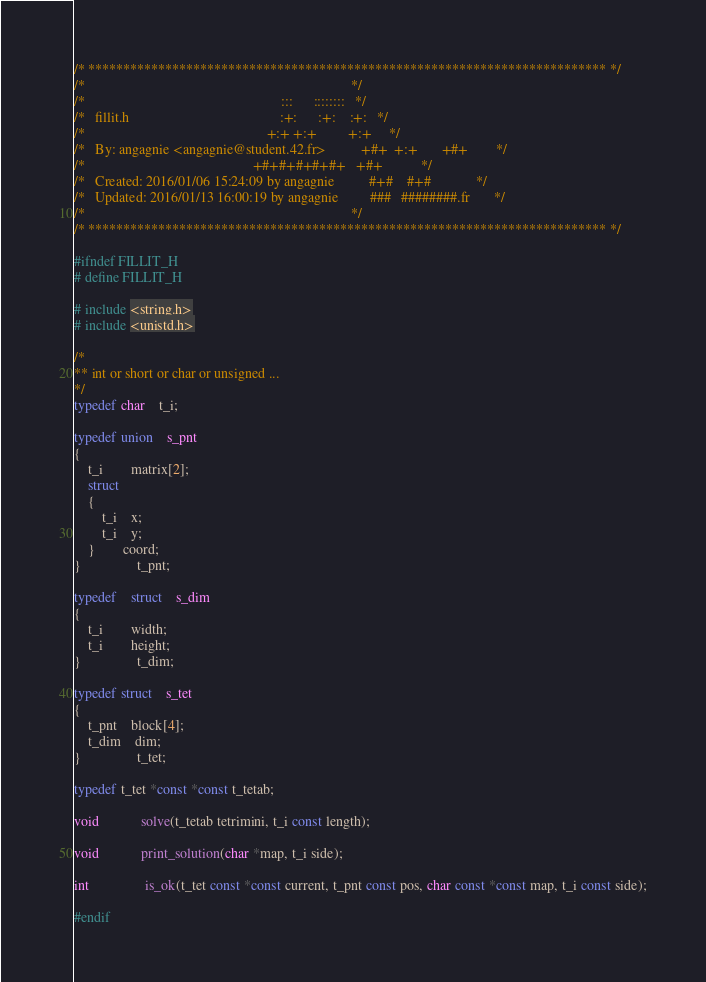Convert code to text. <code><loc_0><loc_0><loc_500><loc_500><_C_>/* ************************************************************************** */
/*                                                                            */
/*                                                        :::      ::::::::   */
/*   fillit.h                                           :+:      :+:    :+:   */
/*                                                    +:+ +:+         +:+     */
/*   By: angagnie <angagnie@student.42.fr>          +#+  +:+       +#+        */
/*                                                +#+#+#+#+#+   +#+           */
/*   Created: 2016/01/06 15:24:09 by angagnie          #+#    #+#             */
/*   Updated: 2016/01/13 16:00:19 by angagnie         ###   ########.fr       */
/*                                                                            */
/* ************************************************************************** */

#ifndef FILLIT_H
# define FILLIT_H

# include <string.h>
# include <unistd.h>

/*
** int or short or char or unsigned ...
*/
typedef char	t_i;

typedef union	s_pnt
{
	t_i		matrix[2];
	struct
	{
		t_i	x;
		t_i	y;
	}		coord;
}				t_pnt;

typedef	struct	s_dim
{
	t_i		width;
	t_i		height;
}				t_dim;

typedef struct	s_tet
{
	t_pnt	block[4];
	t_dim	dim;
}				t_tet;

typedef t_tet *const *const t_tetab;

void			solve(t_tetab tetrimini, t_i const length);

void			print_solution(char *map, t_i side);

int				is_ok(t_tet const *const current, t_pnt const pos, char const *const map, t_i const side);

#endif
</code> 